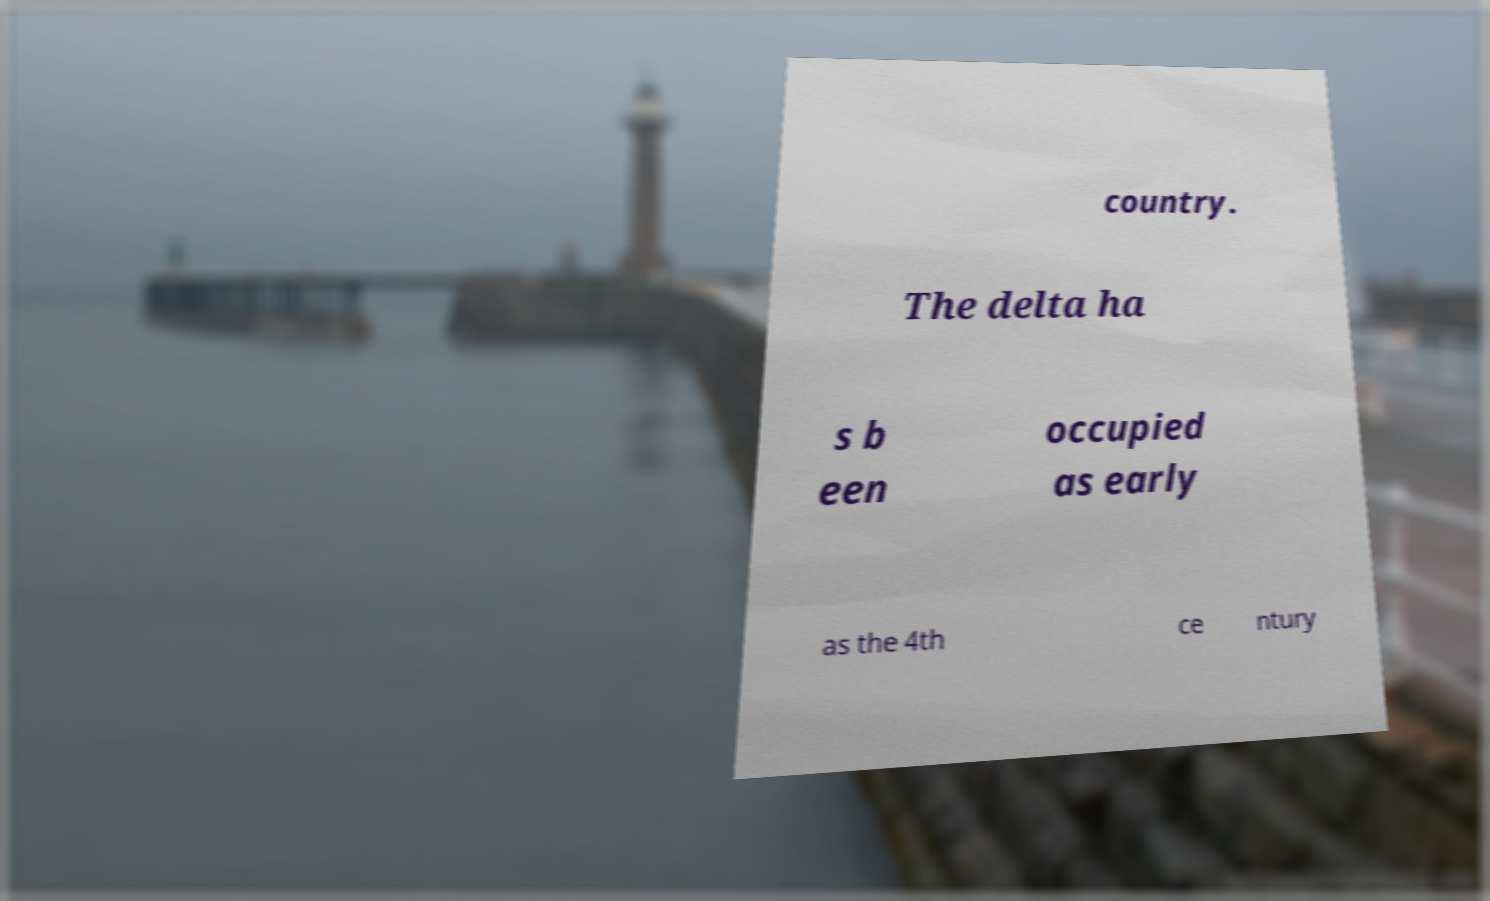Please read and relay the text visible in this image. What does it say? country. The delta ha s b een occupied as early as the 4th ce ntury 